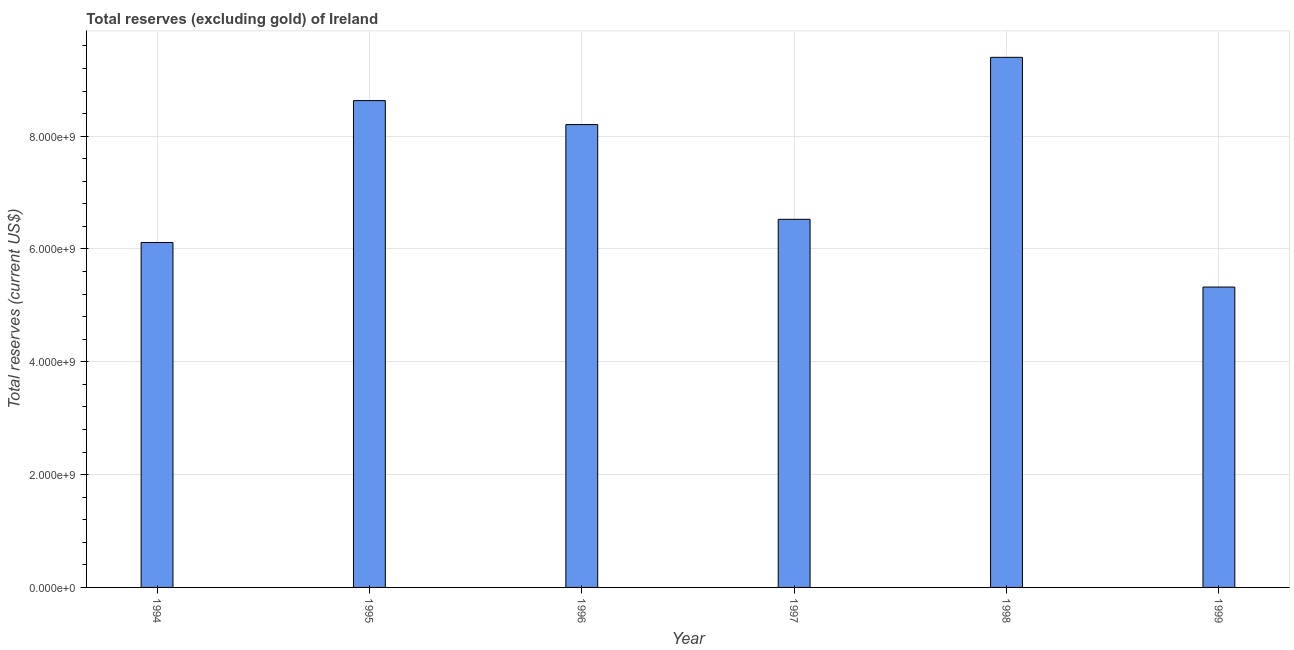Does the graph contain grids?
Your answer should be very brief. Yes. What is the title of the graph?
Keep it short and to the point. Total reserves (excluding gold) of Ireland. What is the label or title of the X-axis?
Your answer should be very brief. Year. What is the label or title of the Y-axis?
Offer a very short reply. Total reserves (current US$). What is the total reserves (excluding gold) in 1997?
Your answer should be compact. 6.53e+09. Across all years, what is the maximum total reserves (excluding gold)?
Give a very brief answer. 9.40e+09. Across all years, what is the minimum total reserves (excluding gold)?
Keep it short and to the point. 5.32e+09. What is the sum of the total reserves (excluding gold)?
Make the answer very short. 4.42e+1. What is the difference between the total reserves (excluding gold) in 1998 and 1999?
Make the answer very short. 4.07e+09. What is the average total reserves (excluding gold) per year?
Your answer should be very brief. 7.37e+09. What is the median total reserves (excluding gold)?
Ensure brevity in your answer.  7.37e+09. In how many years, is the total reserves (excluding gold) greater than 800000000 US$?
Provide a succinct answer. 6. What is the ratio of the total reserves (excluding gold) in 1994 to that in 1999?
Offer a very short reply. 1.15. Is the total reserves (excluding gold) in 1994 less than that in 1998?
Ensure brevity in your answer.  Yes. What is the difference between the highest and the second highest total reserves (excluding gold)?
Your answer should be very brief. 7.67e+08. What is the difference between the highest and the lowest total reserves (excluding gold)?
Make the answer very short. 4.07e+09. In how many years, is the total reserves (excluding gold) greater than the average total reserves (excluding gold) taken over all years?
Give a very brief answer. 3. How many bars are there?
Your answer should be compact. 6. Are all the bars in the graph horizontal?
Your response must be concise. No. Are the values on the major ticks of Y-axis written in scientific E-notation?
Provide a short and direct response. Yes. What is the Total reserves (current US$) in 1994?
Offer a terse response. 6.11e+09. What is the Total reserves (current US$) of 1995?
Your answer should be very brief. 8.63e+09. What is the Total reserves (current US$) of 1996?
Give a very brief answer. 8.21e+09. What is the Total reserves (current US$) of 1997?
Offer a very short reply. 6.53e+09. What is the Total reserves (current US$) of 1998?
Provide a succinct answer. 9.40e+09. What is the Total reserves (current US$) of 1999?
Offer a very short reply. 5.32e+09. What is the difference between the Total reserves (current US$) in 1994 and 1995?
Provide a short and direct response. -2.52e+09. What is the difference between the Total reserves (current US$) in 1994 and 1996?
Provide a short and direct response. -2.09e+09. What is the difference between the Total reserves (current US$) in 1994 and 1997?
Your response must be concise. -4.11e+08. What is the difference between the Total reserves (current US$) in 1994 and 1998?
Offer a very short reply. -3.28e+09. What is the difference between the Total reserves (current US$) in 1994 and 1999?
Give a very brief answer. 7.90e+08. What is the difference between the Total reserves (current US$) in 1995 and 1996?
Give a very brief answer. 4.25e+08. What is the difference between the Total reserves (current US$) in 1995 and 1997?
Provide a short and direct response. 2.10e+09. What is the difference between the Total reserves (current US$) in 1995 and 1998?
Provide a succinct answer. -7.67e+08. What is the difference between the Total reserves (current US$) in 1995 and 1999?
Make the answer very short. 3.31e+09. What is the difference between the Total reserves (current US$) in 1996 and 1997?
Your answer should be compact. 1.68e+09. What is the difference between the Total reserves (current US$) in 1996 and 1998?
Give a very brief answer. -1.19e+09. What is the difference between the Total reserves (current US$) in 1996 and 1999?
Give a very brief answer. 2.88e+09. What is the difference between the Total reserves (current US$) in 1997 and 1998?
Provide a short and direct response. -2.87e+09. What is the difference between the Total reserves (current US$) in 1997 and 1999?
Your response must be concise. 1.20e+09. What is the difference between the Total reserves (current US$) in 1998 and 1999?
Provide a succinct answer. 4.07e+09. What is the ratio of the Total reserves (current US$) in 1994 to that in 1995?
Make the answer very short. 0.71. What is the ratio of the Total reserves (current US$) in 1994 to that in 1996?
Ensure brevity in your answer.  0.74. What is the ratio of the Total reserves (current US$) in 1994 to that in 1997?
Your answer should be compact. 0.94. What is the ratio of the Total reserves (current US$) in 1994 to that in 1998?
Your answer should be very brief. 0.65. What is the ratio of the Total reserves (current US$) in 1994 to that in 1999?
Ensure brevity in your answer.  1.15. What is the ratio of the Total reserves (current US$) in 1995 to that in 1996?
Your answer should be compact. 1.05. What is the ratio of the Total reserves (current US$) in 1995 to that in 1997?
Your answer should be very brief. 1.32. What is the ratio of the Total reserves (current US$) in 1995 to that in 1998?
Your answer should be compact. 0.92. What is the ratio of the Total reserves (current US$) in 1995 to that in 1999?
Offer a terse response. 1.62. What is the ratio of the Total reserves (current US$) in 1996 to that in 1997?
Keep it short and to the point. 1.26. What is the ratio of the Total reserves (current US$) in 1996 to that in 1998?
Ensure brevity in your answer.  0.87. What is the ratio of the Total reserves (current US$) in 1996 to that in 1999?
Provide a short and direct response. 1.54. What is the ratio of the Total reserves (current US$) in 1997 to that in 1998?
Provide a short and direct response. 0.69. What is the ratio of the Total reserves (current US$) in 1997 to that in 1999?
Provide a succinct answer. 1.23. What is the ratio of the Total reserves (current US$) in 1998 to that in 1999?
Your response must be concise. 1.76. 